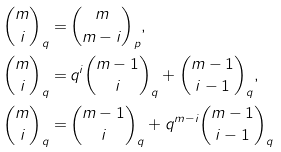Convert formula to latex. <formula><loc_0><loc_0><loc_500><loc_500>{ m \choose i } _ { q } = & \, { m \choose m - i } _ { p } , \\ { m \choose i } _ { q } = & \, q ^ { i } { m - 1 \choose i } _ { q } + { m - 1 \choose i - 1 } _ { q } , \\ { m \choose i } _ { q } = & \, { m - 1 \choose i } _ { q } + q ^ { m - i } { m - 1 \choose i - 1 } _ { q }</formula> 